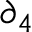<formula> <loc_0><loc_0><loc_500><loc_500>\partial _ { 4 }</formula> 